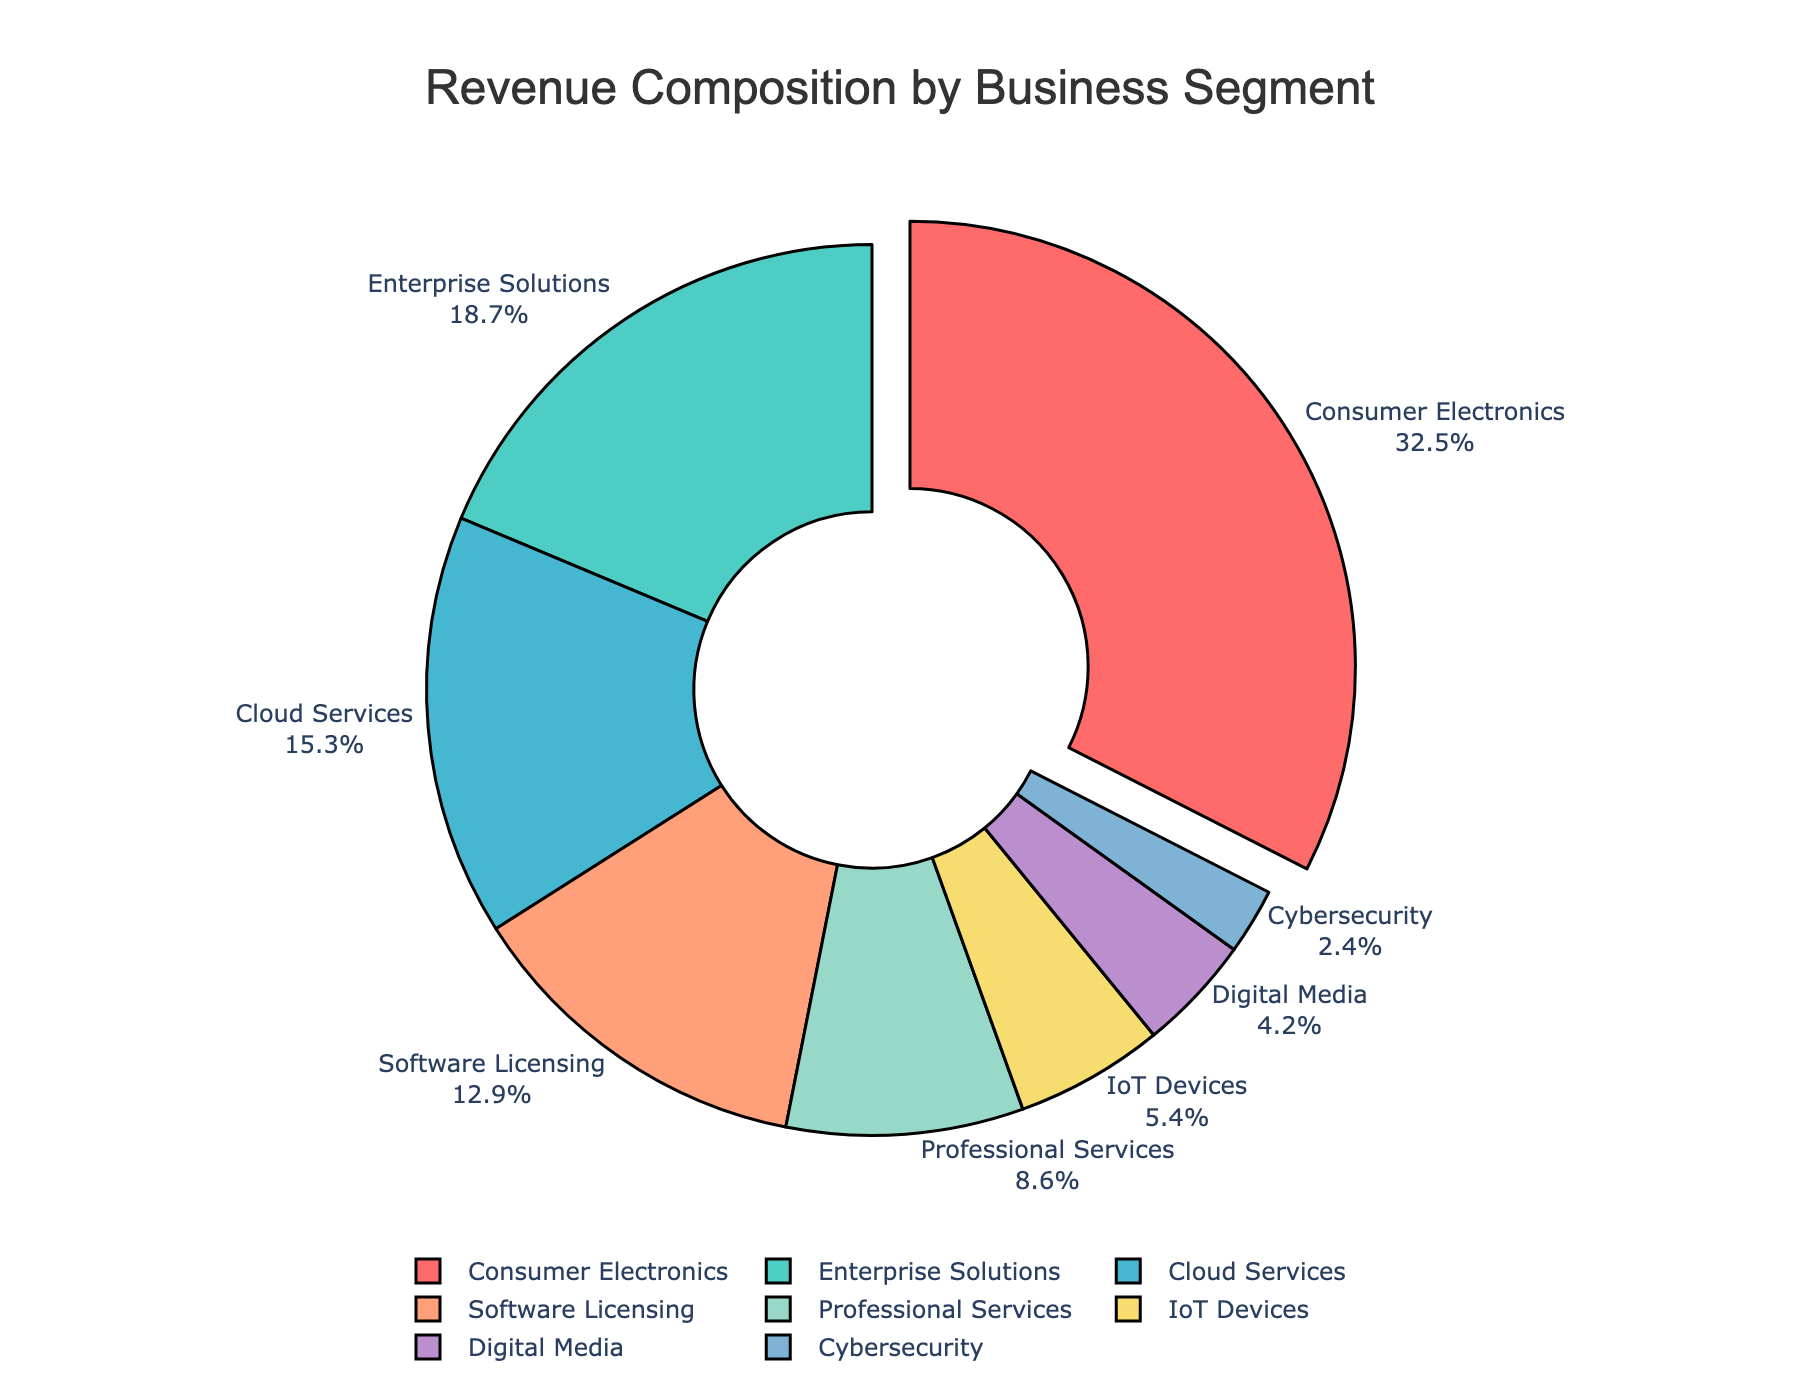What's the largest revenue source? The largest section of the pie chart represents the business segment with the highest revenue percentage. This is identified by the segment pulled out from the pie.
Answer: Consumer Electronics What's the combined revenue percentage of Enterprise Solutions and Cloud Services? To find this, sum the revenue percentages of Enterprise Solutions and Cloud Services. 18.7 + 15.3 = 34
Answer: 34 Which business segment has the smallest revenue percentage? The smallest section of the pie chart represents the business segment with the lowest revenue percentage.
Answer: Cybersecurity How much more does Consumer Electronics contribute to revenue than Software Licensing? Subtract the revenue percentage of Software Licensing from that of Consumer Electronics: 32.5 - 12.9 = 19.6
Answer: 19.6 List the business segments in descending order of their revenue contribution. The pie chart segments are ordered based on their size from largest to smallest: Consumer Electronics, Enterprise Solutions, Cloud Services, Software Licensing, Professional Services, IoT Devices, Digital Media, Cybersecurity.
Answer: Consumer Electronics, Enterprise Solutions, Cloud Services, Software Licensing, Professional Services, IoT Devices, Digital Media, Cybersecurity Which two segments together make up approximately a quarter of the total revenue? Look for two segments whose combined percentage is closest to 25%. Professional Services (8.6) and IoT Devices (5.4) add up to 14, combine with Digital Media (4.2) sums up to 18.2, which is significant but not very close. Cybersecurity with IoT Devices is 7.8 which is close. Consumer Electronics and Software Licensing could be another one: 32.5 + 12.9 = 45.4. Professional Services and Cybersecurity is the closest (8.6 + 2.4) = 11.
Answer: Professional Services and Cybersecurity What's the difference in revenue percentage between the third and fourth largest business segments? Identify the third and fourth segments: Cloud Services (15.3) and Software Licensing (12.9), then subtract the smaller from the larger: 15.3 - 12.9 = 2.4
Answer: 2.4 Which segment contributes more to the revenue, IoT Devices or Digital Media? Compare the sizes of the two segments: IoT Devices (5.4) is larger than Digital Media (4.2)
Answer: IoT Devices What percentage of the revenue does the smallest three segments contribute together? Sum the revenue percentages of the three smallest segments: IoT Devices (5.4), Digital Media (4.2), and Cybersecurity (2.4). 5.4 + 4.2 + 2.4 = 12
Answer: 12 Which part of the chart is represented by the blue color? Identify the segment shown in blue from the chart: based on the provided colors, it corresponds to Cloud Services.
Answer: Cloud Services 